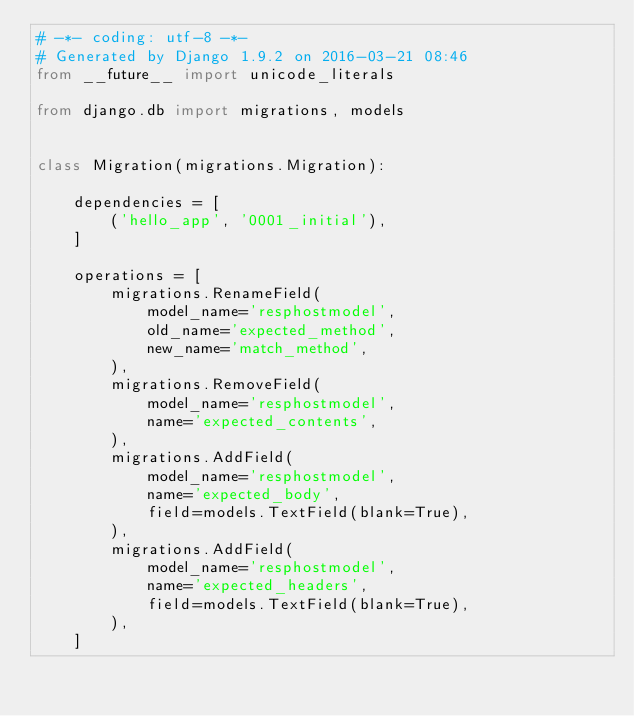Convert code to text. <code><loc_0><loc_0><loc_500><loc_500><_Python_># -*- coding: utf-8 -*-
# Generated by Django 1.9.2 on 2016-03-21 08:46
from __future__ import unicode_literals

from django.db import migrations, models


class Migration(migrations.Migration):

    dependencies = [
        ('hello_app', '0001_initial'),
    ]

    operations = [
        migrations.RenameField(
            model_name='resphostmodel',
            old_name='expected_method',
            new_name='match_method',
        ),
        migrations.RemoveField(
            model_name='resphostmodel',
            name='expected_contents',
        ),
        migrations.AddField(
            model_name='resphostmodel',
            name='expected_body',
            field=models.TextField(blank=True),
        ),
        migrations.AddField(
            model_name='resphostmodel',
            name='expected_headers',
            field=models.TextField(blank=True),
        ),
    ]
</code> 